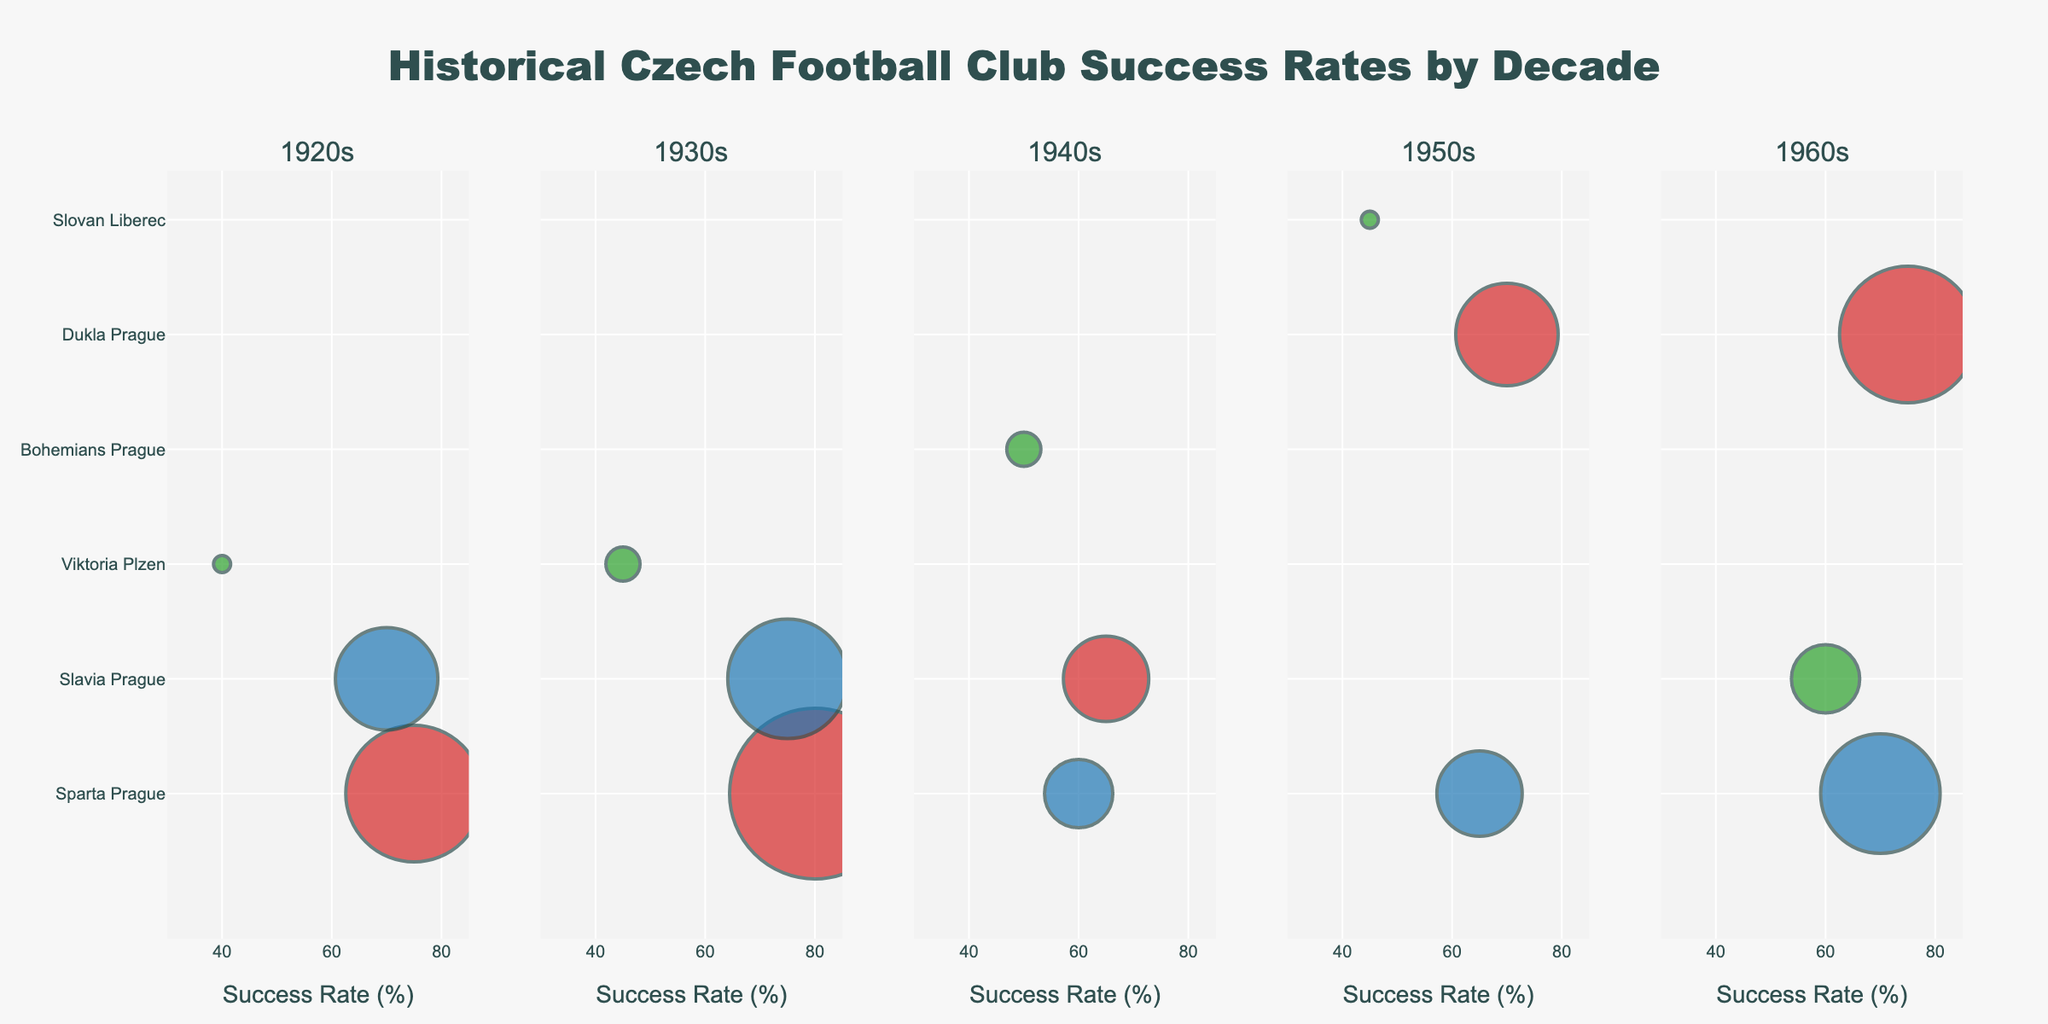What is the title of the figure? The title of the figure is typically placed at the top center of the plot. It summarizes the overall content of the visual
Answer: Catalyst Efficiency vs. Temperature for Platinum Alloys How many data points are in each subplot? Each subplot appears to have a dot for each unique temperature reading indicated on the x-axis. Count these points to determine the number per subplot
Answer: 10 Which platinum alloy has the highest efficiency at 90°C? Each subplot represents a different platinum alloy, and the y-axis indicates efficiency. Locate the data point corresponding to 90°C and compare the efficiency values in each subplot
Answer: Pt-Co Which alloy shows the smallest increase in efficiency from 30°C to 120°C? To determine this, subtract the efficiency value at 30°C from the efficiency value at 120°C for each alloy, and compare the differences
Answer: Pt-Cu How does the efficiency of Pt-Ni change from 60°C to 80°C? Find the efficiency values of Pt-Ni at 60°C and 80°C, and calculate the difference by subtracting the value at 60°C from the value at 80°C
Answer: Increased by 8.5% At which temperature do Pt-Co and Pt-Ni efficiencies become most similar? Compare the efficiencies of Pt-Co and Pt-Ni at each temperature and find the point where the difference between their efficiencies is the smallest
Answer: 120°C How much more efficient is Pt-Co compared to Pt-Cu at 50°C? Subtract the efficiency of Pt-Cu at 50°C from the efficiency of Pt-Co at 50°C
Answer: 9.5% Which alloy's efficiency surpasses 80% first as the temperature increases? Starting from the lowest temperature, check the y-values for each alloy and find which alloy first crosses the 80% mark
Answer: Pt-Co Between Pt-Fe and Pt-Cu, which has a steeper slope in efficiency from 70°C to 100°C? The slope can be approximated by finding the change in efficiency (rise) over the change in temperature (run). Calculate this for both Pt-Fe and Pt-Cu and compare
Answer: Pt-Fe At 110°C, how much does Pt-Fe's efficiency fall short of Pt-Co's efficiency? Subtract Pt-Fe's efficiency at 110°C from Pt-Co's efficiency at the same temperature
Answer: 6.0% 